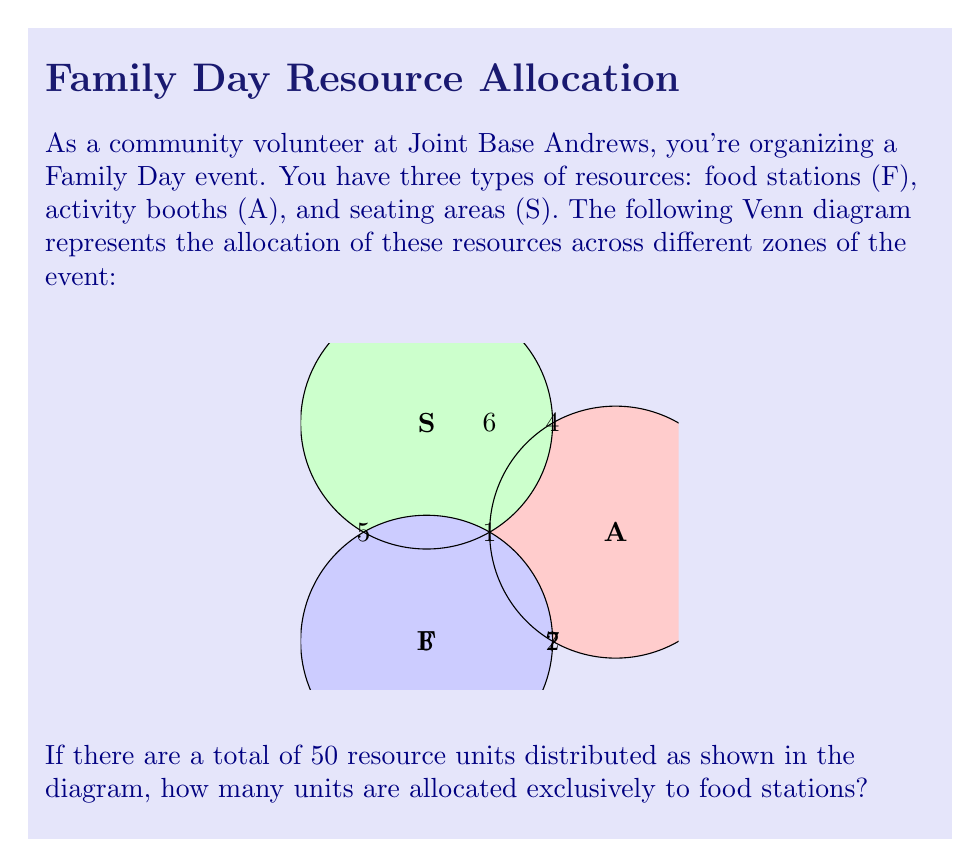Could you help me with this problem? Let's approach this step-by-step using set theory:

1) Let's define our sets:
   F: Food stations
   A: Activity booths
   S: Seating areas

2) The numbers in each region of the Venn diagram represent the number of resource units in that specific intersection or exclusive area.

3) We need to find |F| - |(F∩A) ∪ (F∩S) ∪ (F∩A∩S)|, which is the number of elements exclusively in F.

4) We're given that there are 50 total resource units. Let's express this using set notation:

   |F ∪ A ∪ S| = 50

5) Using the inclusion-exclusion principle:

   |F ∪ A ∪ S| = |F| + |A| + |S| - |F∩A| - |F∩S| - |A∩S| + |F∩A∩S|

6) From the diagram, we can see:
   |F∩A∩S| = 1
   |F∩A| = 1 + 2 = 3
   |F∩S| = 1 + 4 = 5
   |A∩S| = 1 + 3 = 4

7) Let x be the number of units exclusively in F. Then:

   50 = x + 5 + 6 + 7 + 3 + 5 + 4 - 1

8) Solving for x:

   50 = x + 29
   x = 50 - 29 = 21

Therefore, 21 resource units are allocated exclusively to food stations.
Answer: 21 